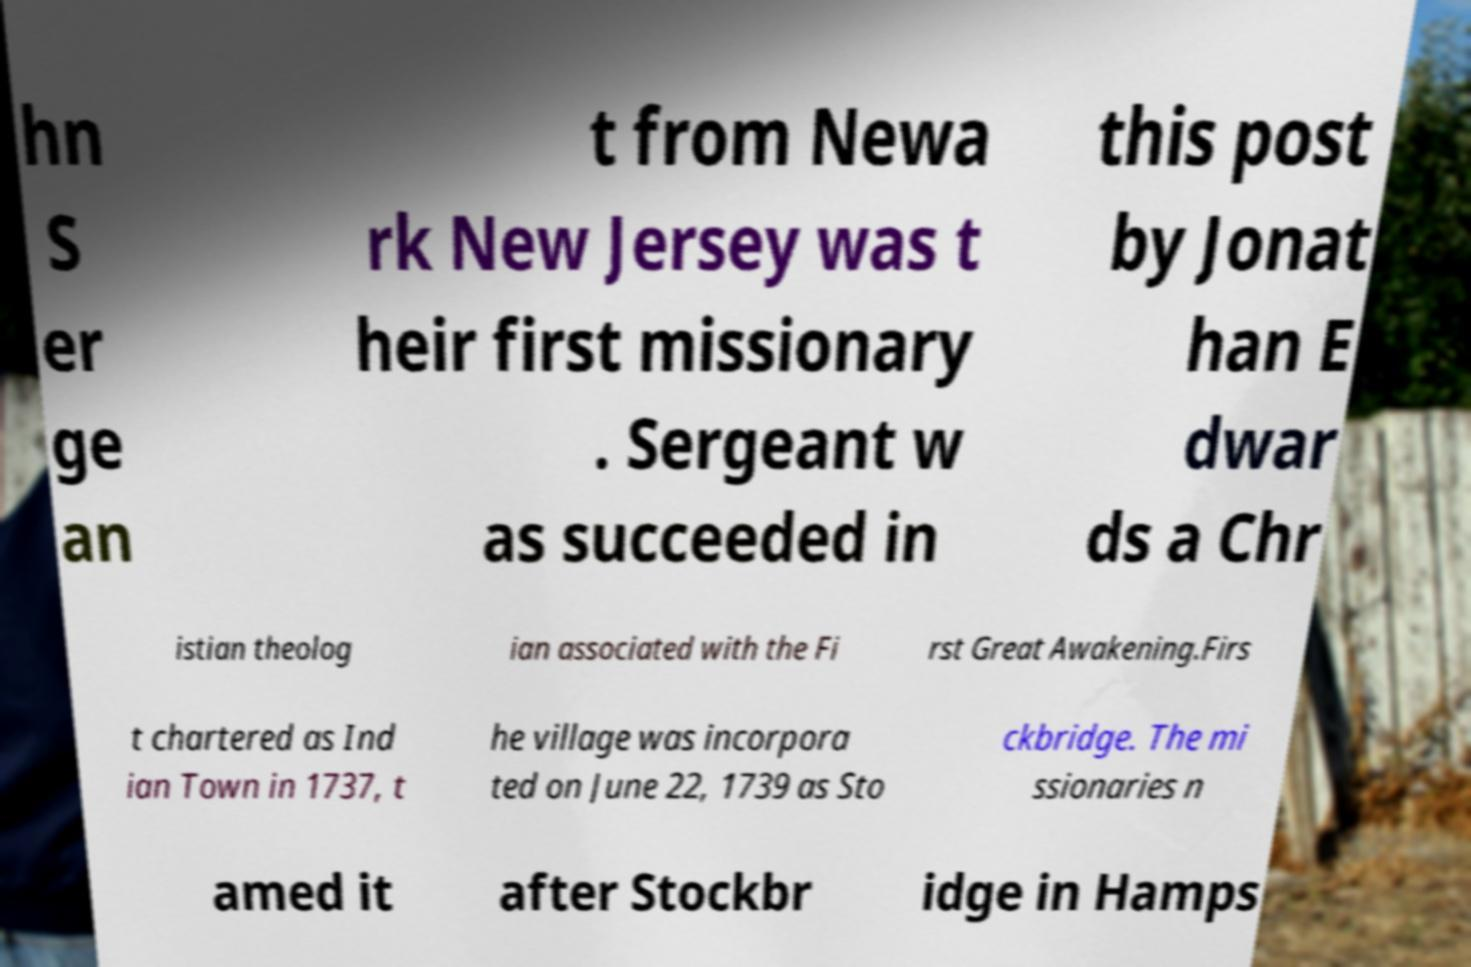Please identify and transcribe the text found in this image. hn S er ge an t from Newa rk New Jersey was t heir first missionary . Sergeant w as succeeded in this post by Jonat han E dwar ds a Chr istian theolog ian associated with the Fi rst Great Awakening.Firs t chartered as Ind ian Town in 1737, t he village was incorpora ted on June 22, 1739 as Sto ckbridge. The mi ssionaries n amed it after Stockbr idge in Hamps 